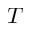Convert formula to latex. <formula><loc_0><loc_0><loc_500><loc_500>T</formula> 